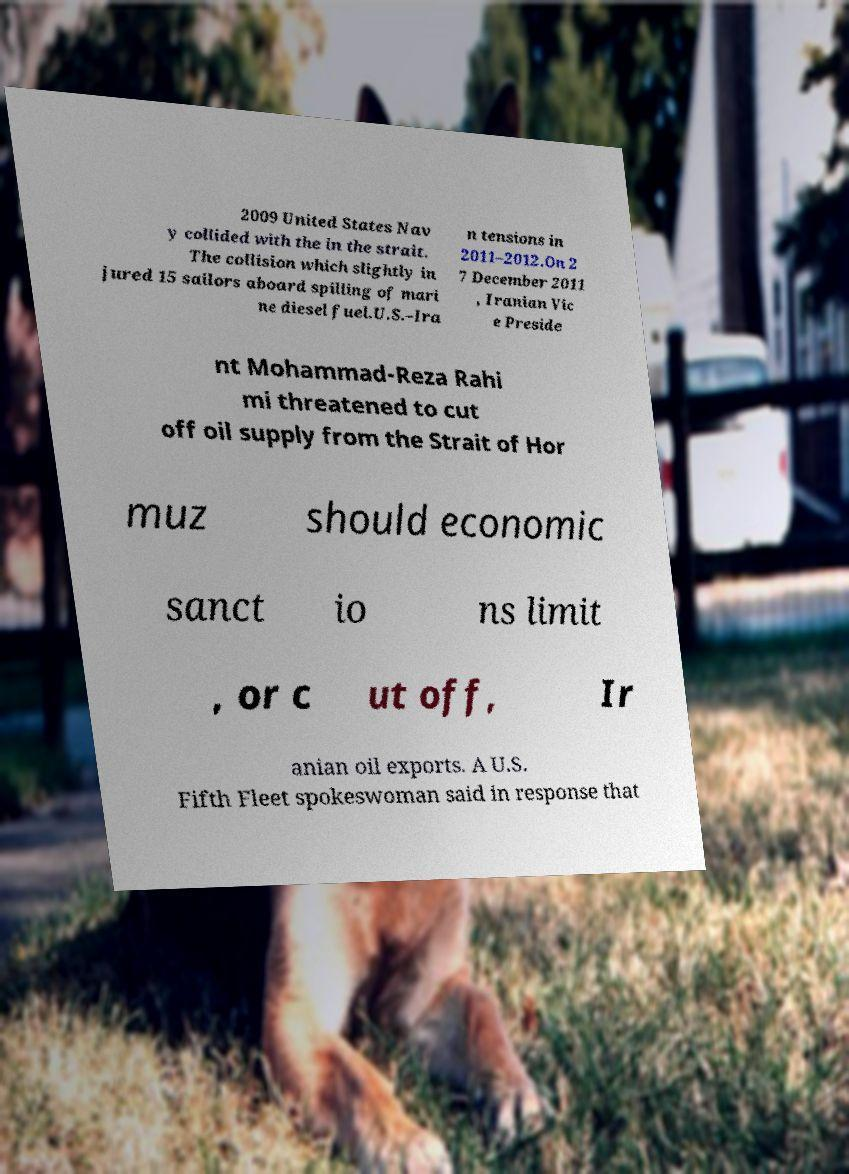There's text embedded in this image that I need extracted. Can you transcribe it verbatim? 2009 United States Nav y collided with the in the strait. The collision which slightly in jured 15 sailors aboard spilling of mari ne diesel fuel.U.S.–Ira n tensions in 2011–2012.On 2 7 December 2011 , Iranian Vic e Preside nt Mohammad-Reza Rahi mi threatened to cut off oil supply from the Strait of Hor muz should economic sanct io ns limit , or c ut off, Ir anian oil exports. A U.S. Fifth Fleet spokeswoman said in response that 